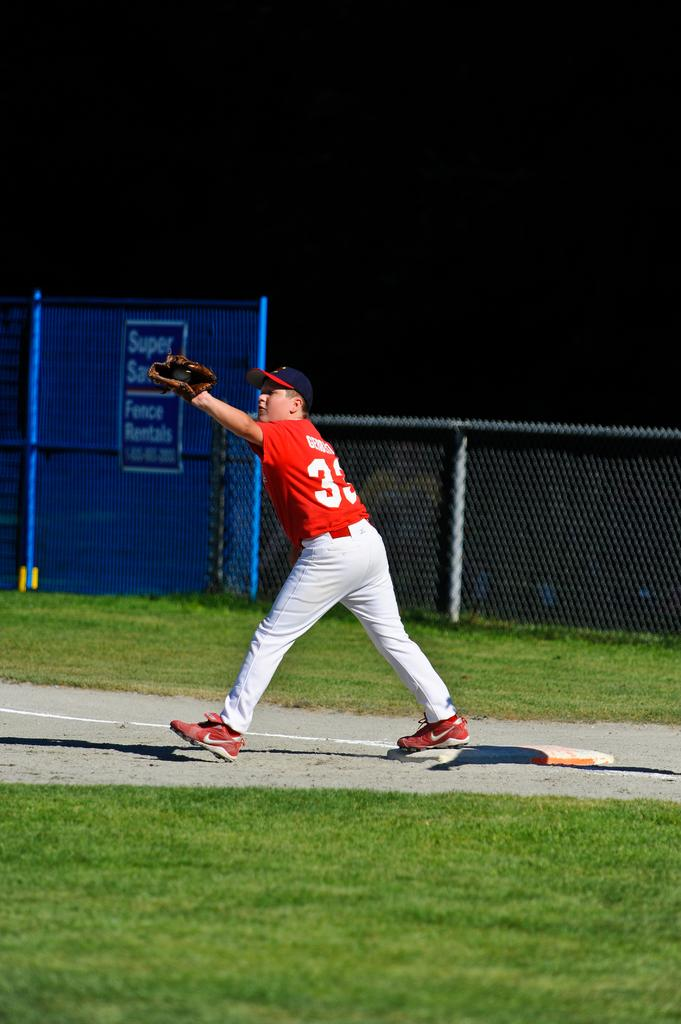<image>
Write a terse but informative summary of the picture. a person playing a sport with the number 3 on their back 